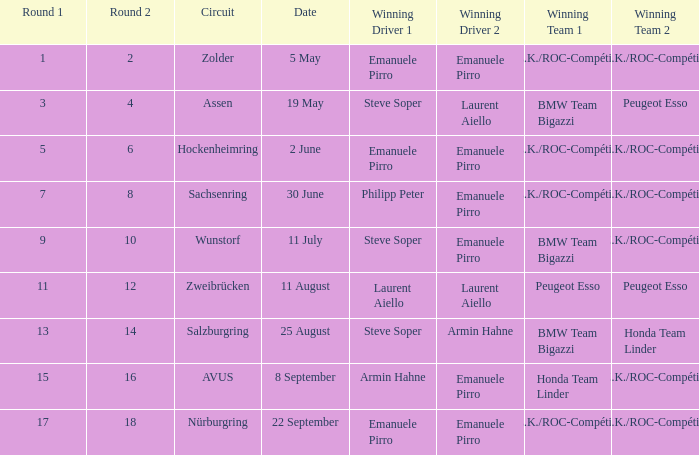Who is the winning driver of the race on 2 June with a.z.k./roc-compétition a.z.k./roc-compétition as the winning team? Emanuele Pirro Emanuele Pirro. 